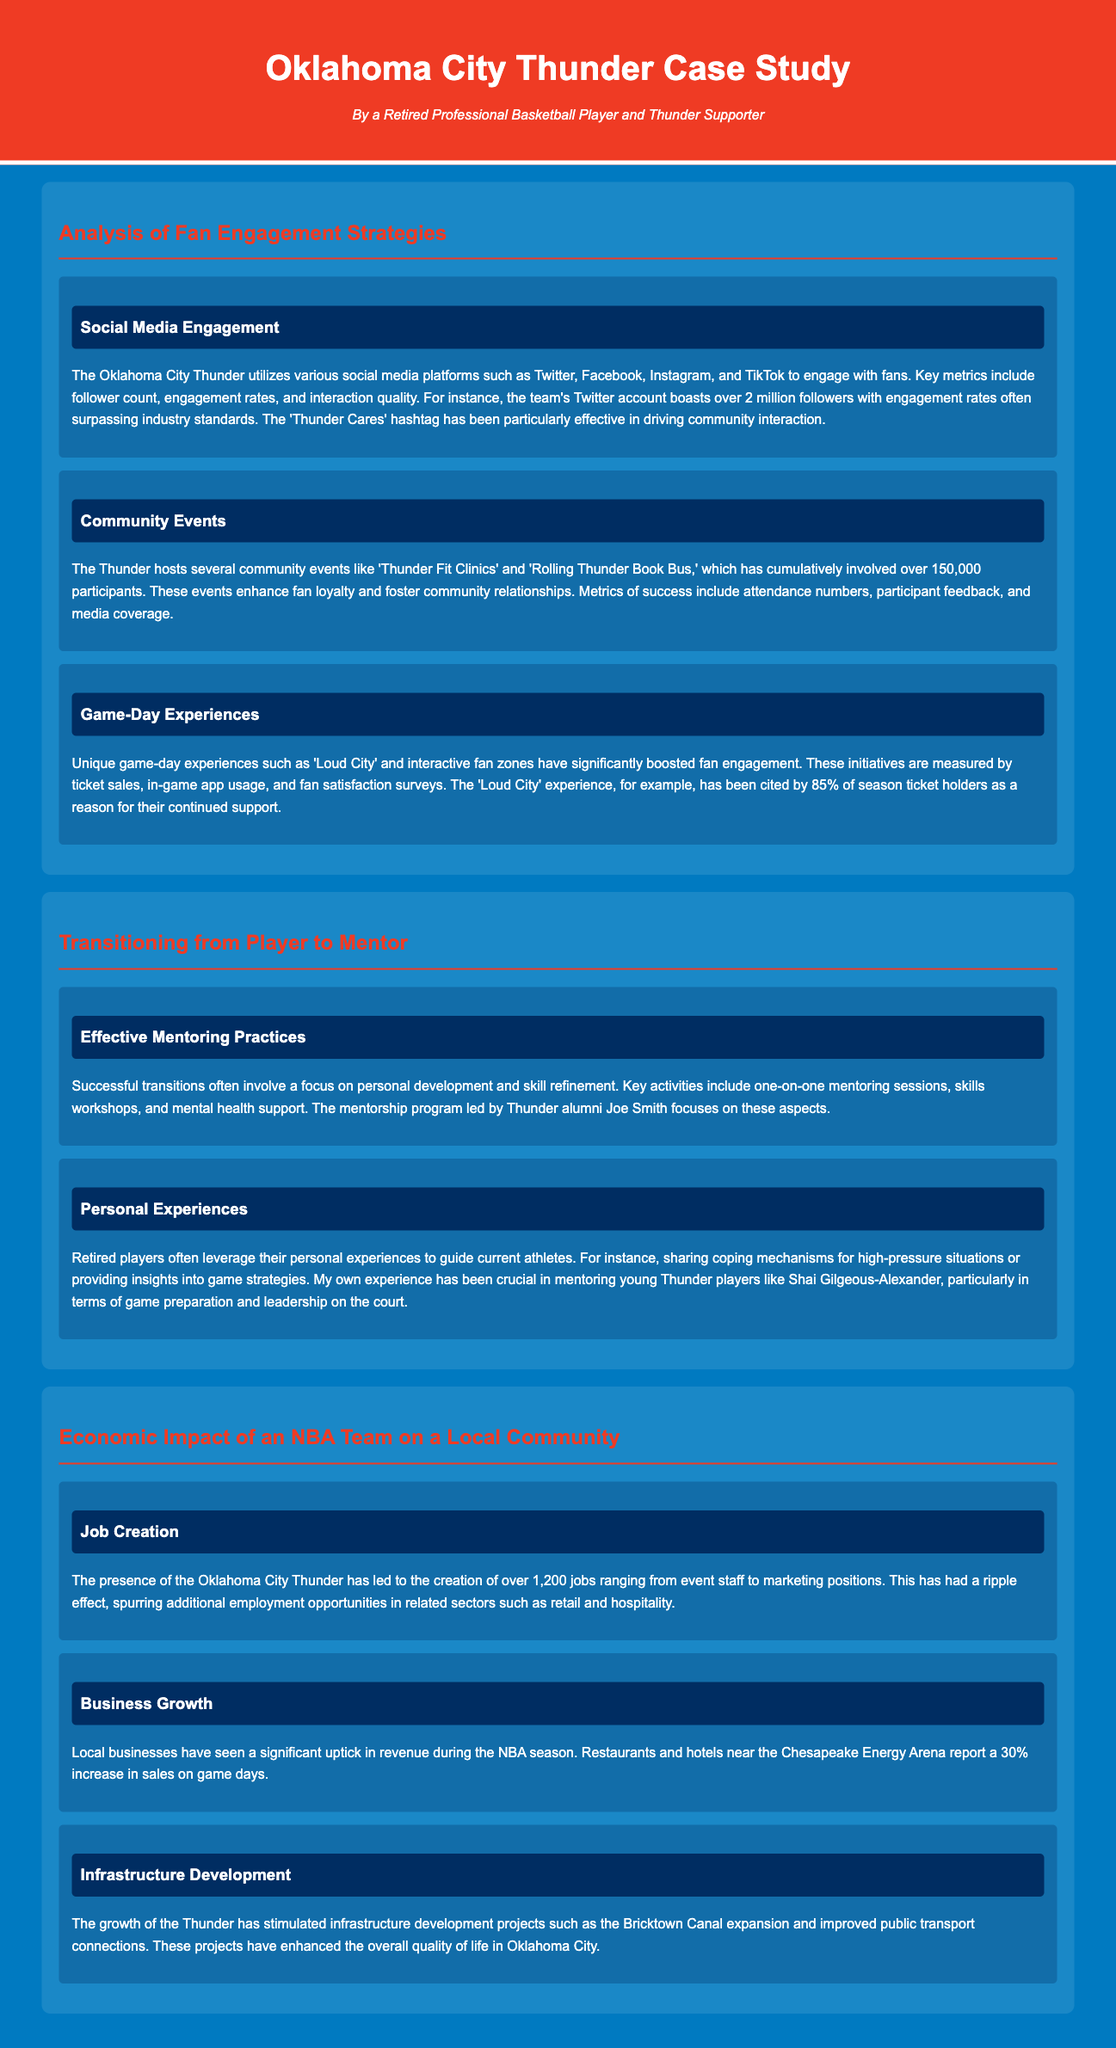What is the Twitter follower count for the Oklahoma City Thunder? The document states that the team's Twitter account boasts over 2 million followers.
Answer: over 2 million How many attendees were involved in community events? The document mentions that community events have cumulatively involved over 150,000 participants.
Answer: over 150,000 What percentage of season ticket holders cited 'Loud City' as a reason for their continued support? According to the document, 85% of season ticket holders mentioned 'Loud City' as a reason for their support.
Answer: 85% How many jobs were created due to the presence of the Oklahoma City Thunder? The document states that the creation of over 1,200 jobs has occurred due to the Thunder's presence.
Answer: over 1,200 What was the reported increase in sales for local businesses on game days? The document indicates a 30% increase in revenue during the NBA season for local businesses.
Answer: 30% What is one of the main focuses of the Thunder's mentorship program? The document highlights that the mentorship program led by Joe Smith focuses on personal development and skill refinement.
Answer: personal development How many community outreach initiatives are detailed in the document? The document discusses several community outreach initiatives, specifically mentioning programs like 'Thunder Fit Clinics' and 'Rolling Thunder Book Bus.'
Answer: several What community project was stimulated by the growth of the Thunder? The document notes that the Bricktown Canal expansion is one of the infrastructure development projects stimulated by the Thunder's growth.
Answer: Bricktown Canal expansion 